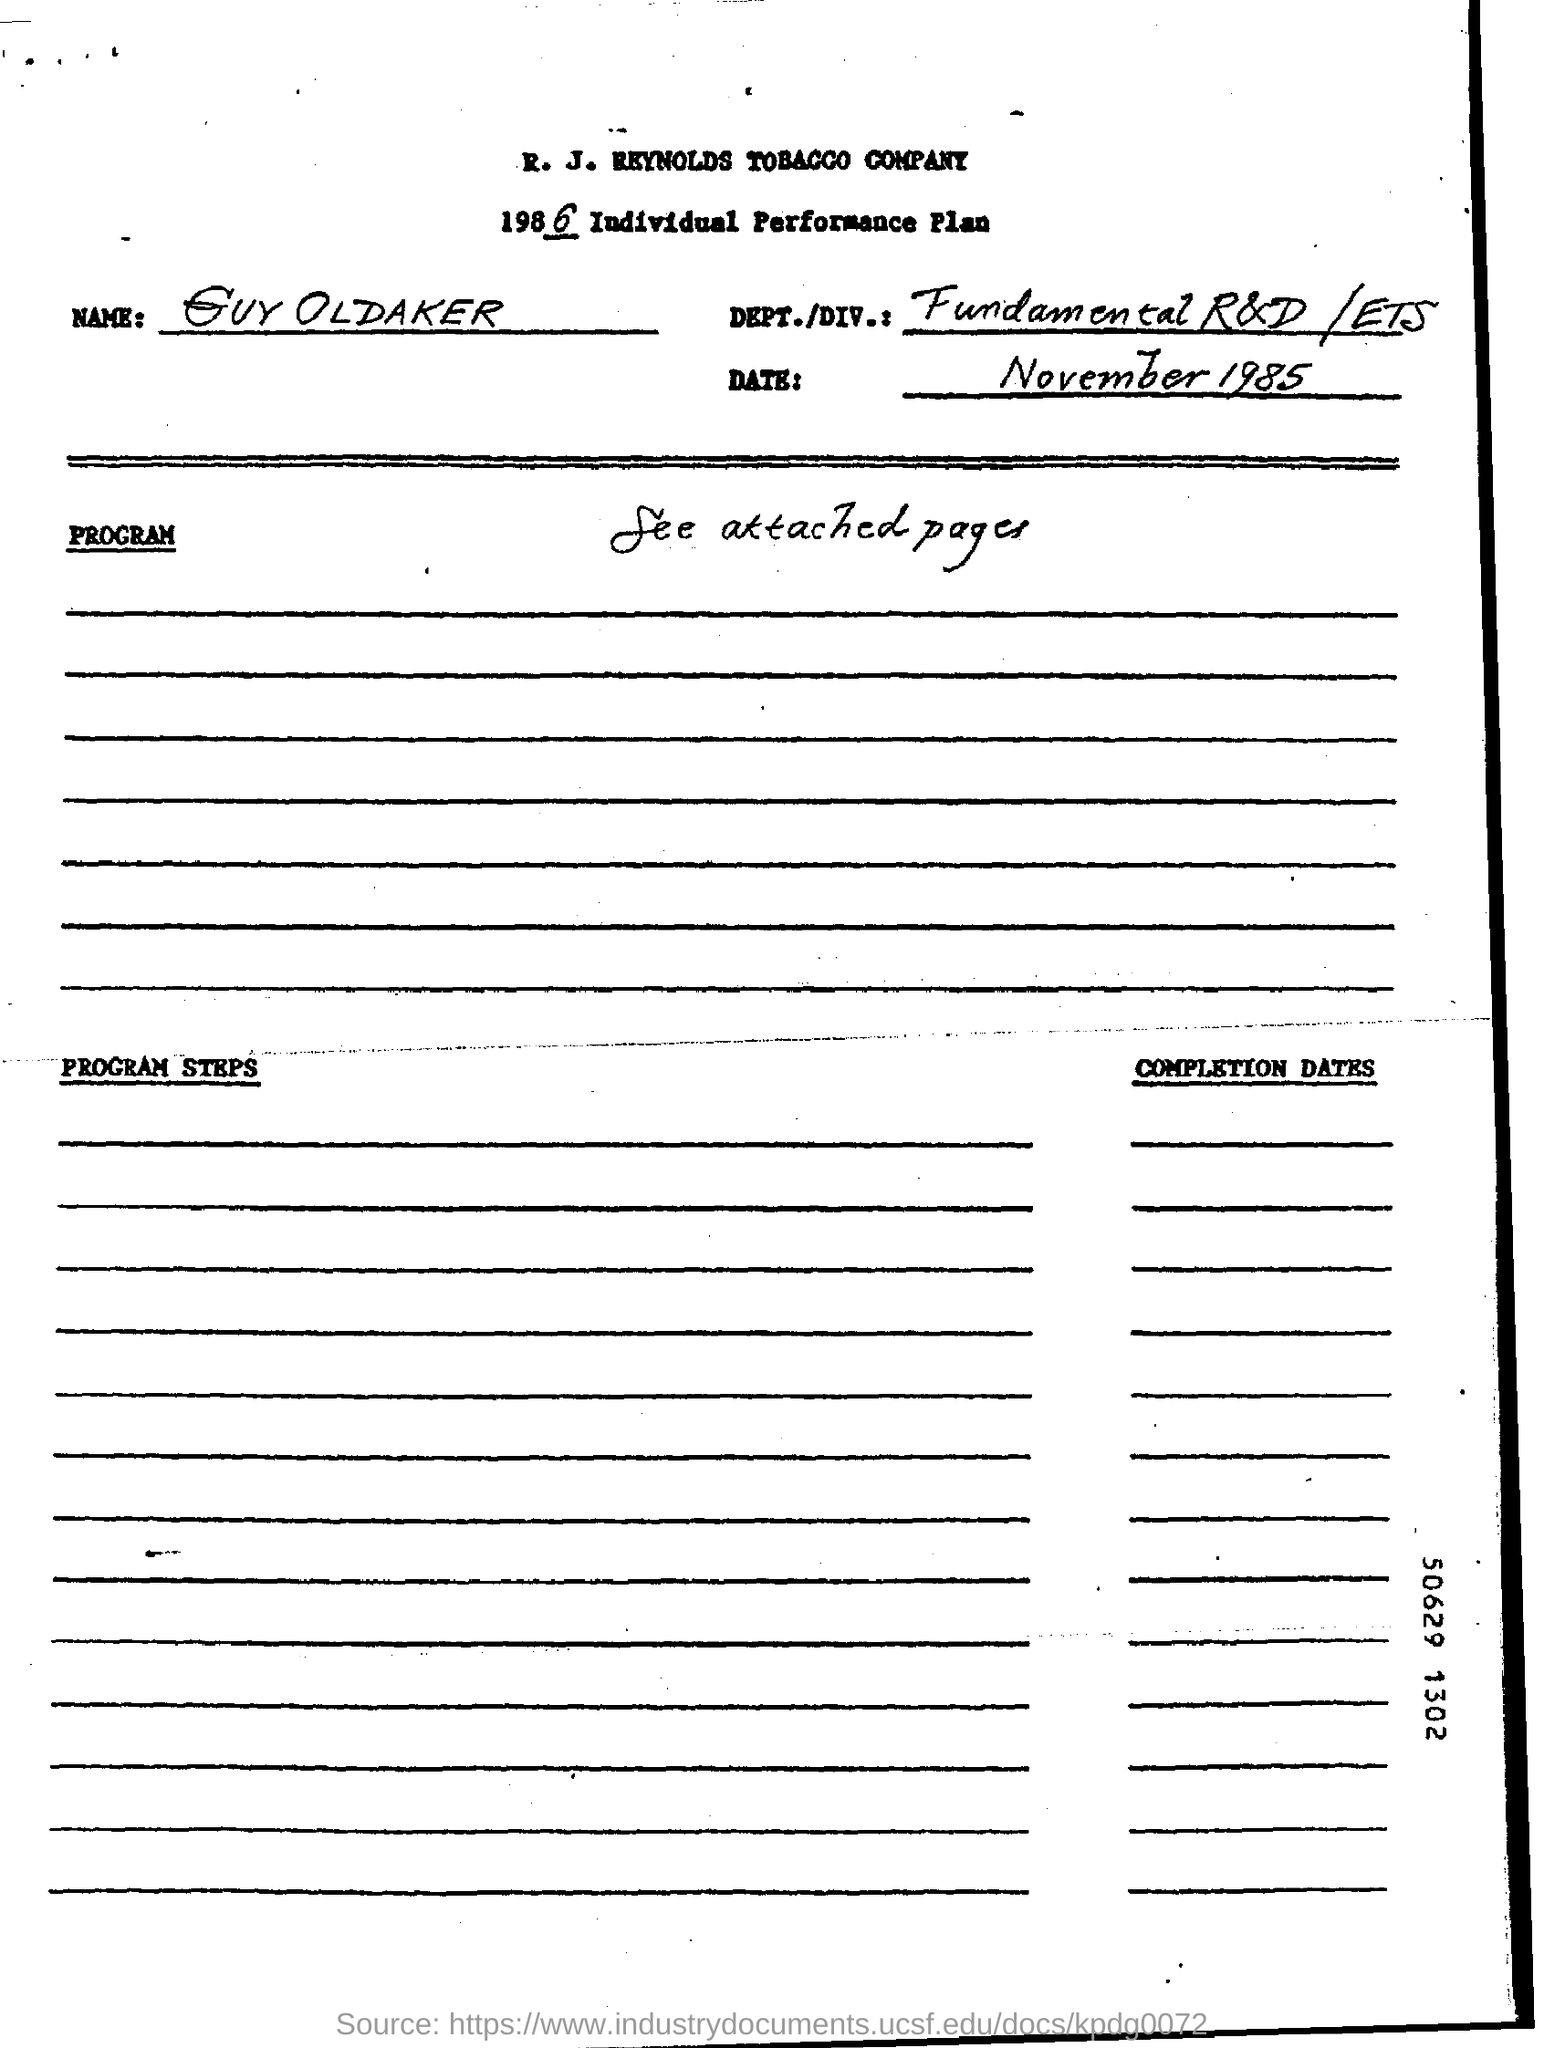Point out several critical features in this image. The company name is R. J. Reynolds Tobacco Company. The date mentioned at the top of the document is November 1985. The DEPT./DIV.: Field in the documentation states 'Fundamental R&D /ETS'. 